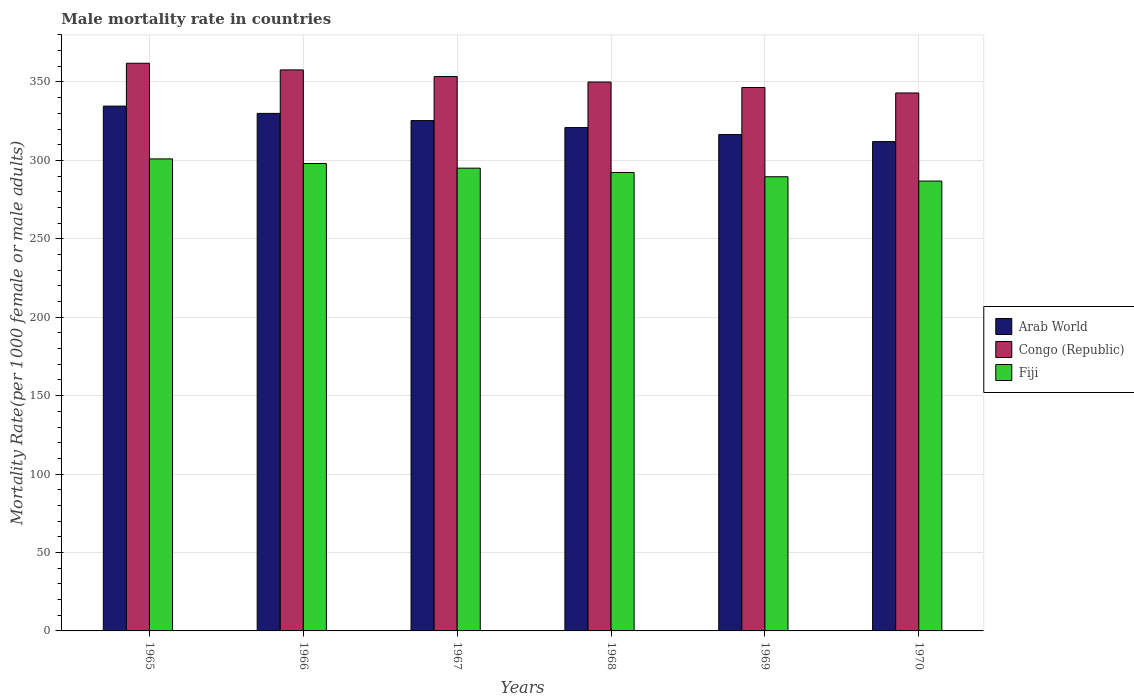How many different coloured bars are there?
Your answer should be very brief. 3. How many groups of bars are there?
Your answer should be compact. 6. Are the number of bars per tick equal to the number of legend labels?
Provide a succinct answer. Yes. Are the number of bars on each tick of the X-axis equal?
Your answer should be compact. Yes. How many bars are there on the 2nd tick from the left?
Offer a terse response. 3. How many bars are there on the 3rd tick from the right?
Your answer should be compact. 3. What is the male mortality rate in Congo (Republic) in 1969?
Your answer should be very brief. 346.49. Across all years, what is the maximum male mortality rate in Arab World?
Provide a succinct answer. 334.63. Across all years, what is the minimum male mortality rate in Fiji?
Give a very brief answer. 286.84. In which year was the male mortality rate in Arab World maximum?
Offer a terse response. 1965. What is the total male mortality rate in Congo (Republic) in the graph?
Your answer should be compact. 2112.6. What is the difference between the male mortality rate in Arab World in 1967 and that in 1970?
Your answer should be compact. 13.39. What is the difference between the male mortality rate in Arab World in 1965 and the male mortality rate in Congo (Republic) in 1970?
Provide a succinct answer. -8.37. What is the average male mortality rate in Congo (Republic) per year?
Keep it short and to the point. 352.1. In the year 1967, what is the difference between the male mortality rate in Arab World and male mortality rate in Fiji?
Provide a succinct answer. 30.32. What is the ratio of the male mortality rate in Arab World in 1966 to that in 1968?
Give a very brief answer. 1.03. What is the difference between the highest and the second highest male mortality rate in Fiji?
Offer a very short reply. 2.95. What is the difference between the highest and the lowest male mortality rate in Arab World?
Your response must be concise. 22.63. Is the sum of the male mortality rate in Arab World in 1967 and 1969 greater than the maximum male mortality rate in Congo (Republic) across all years?
Your answer should be very brief. Yes. What does the 2nd bar from the left in 1966 represents?
Ensure brevity in your answer.  Congo (Republic). What does the 3rd bar from the right in 1970 represents?
Your answer should be compact. Arab World. How many bars are there?
Give a very brief answer. 18. What is the difference between two consecutive major ticks on the Y-axis?
Your answer should be very brief. 50. Are the values on the major ticks of Y-axis written in scientific E-notation?
Your response must be concise. No. How many legend labels are there?
Ensure brevity in your answer.  3. What is the title of the graph?
Provide a succinct answer. Male mortality rate in countries. What is the label or title of the X-axis?
Your answer should be compact. Years. What is the label or title of the Y-axis?
Give a very brief answer. Mortality Rate(per 1000 female or male adults). What is the Mortality Rate(per 1000 female or male adults) of Arab World in 1965?
Give a very brief answer. 334.63. What is the Mortality Rate(per 1000 female or male adults) in Congo (Republic) in 1965?
Keep it short and to the point. 361.95. What is the Mortality Rate(per 1000 female or male adults) of Fiji in 1965?
Ensure brevity in your answer.  300.96. What is the Mortality Rate(per 1000 female or male adults) of Arab World in 1966?
Ensure brevity in your answer.  329.99. What is the Mortality Rate(per 1000 female or male adults) in Congo (Republic) in 1966?
Keep it short and to the point. 357.71. What is the Mortality Rate(per 1000 female or male adults) of Fiji in 1966?
Ensure brevity in your answer.  298.01. What is the Mortality Rate(per 1000 female or male adults) in Arab World in 1967?
Offer a terse response. 325.39. What is the Mortality Rate(per 1000 female or male adults) of Congo (Republic) in 1967?
Keep it short and to the point. 353.47. What is the Mortality Rate(per 1000 female or male adults) of Fiji in 1967?
Offer a terse response. 295.07. What is the Mortality Rate(per 1000 female or male adults) in Arab World in 1968?
Provide a succinct answer. 320.95. What is the Mortality Rate(per 1000 female or male adults) of Congo (Republic) in 1968?
Your response must be concise. 349.98. What is the Mortality Rate(per 1000 female or male adults) in Fiji in 1968?
Your answer should be compact. 292.33. What is the Mortality Rate(per 1000 female or male adults) of Arab World in 1969?
Ensure brevity in your answer.  316.49. What is the Mortality Rate(per 1000 female or male adults) in Congo (Republic) in 1969?
Your response must be concise. 346.49. What is the Mortality Rate(per 1000 female or male adults) in Fiji in 1969?
Provide a succinct answer. 289.58. What is the Mortality Rate(per 1000 female or male adults) in Arab World in 1970?
Your response must be concise. 312. What is the Mortality Rate(per 1000 female or male adults) of Congo (Republic) in 1970?
Your response must be concise. 343. What is the Mortality Rate(per 1000 female or male adults) of Fiji in 1970?
Your answer should be compact. 286.84. Across all years, what is the maximum Mortality Rate(per 1000 female or male adults) of Arab World?
Offer a very short reply. 334.63. Across all years, what is the maximum Mortality Rate(per 1000 female or male adults) of Congo (Republic)?
Provide a short and direct response. 361.95. Across all years, what is the maximum Mortality Rate(per 1000 female or male adults) of Fiji?
Ensure brevity in your answer.  300.96. Across all years, what is the minimum Mortality Rate(per 1000 female or male adults) of Arab World?
Offer a very short reply. 312. Across all years, what is the minimum Mortality Rate(per 1000 female or male adults) in Congo (Republic)?
Ensure brevity in your answer.  343. Across all years, what is the minimum Mortality Rate(per 1000 female or male adults) in Fiji?
Your response must be concise. 286.84. What is the total Mortality Rate(per 1000 female or male adults) in Arab World in the graph?
Give a very brief answer. 1939.45. What is the total Mortality Rate(per 1000 female or male adults) in Congo (Republic) in the graph?
Your answer should be compact. 2112.6. What is the total Mortality Rate(per 1000 female or male adults) in Fiji in the graph?
Your answer should be compact. 1762.8. What is the difference between the Mortality Rate(per 1000 female or male adults) in Arab World in 1965 and that in 1966?
Your answer should be compact. 4.64. What is the difference between the Mortality Rate(per 1000 female or male adults) in Congo (Republic) in 1965 and that in 1966?
Offer a terse response. 4.24. What is the difference between the Mortality Rate(per 1000 female or male adults) in Fiji in 1965 and that in 1966?
Your response must be concise. 2.95. What is the difference between the Mortality Rate(per 1000 female or male adults) in Arab World in 1965 and that in 1967?
Your response must be concise. 9.24. What is the difference between the Mortality Rate(per 1000 female or male adults) in Congo (Republic) in 1965 and that in 1967?
Your response must be concise. 8.47. What is the difference between the Mortality Rate(per 1000 female or male adults) of Fiji in 1965 and that in 1967?
Your answer should be very brief. 5.89. What is the difference between the Mortality Rate(per 1000 female or male adults) in Arab World in 1965 and that in 1968?
Ensure brevity in your answer.  13.68. What is the difference between the Mortality Rate(per 1000 female or male adults) in Congo (Republic) in 1965 and that in 1968?
Provide a succinct answer. 11.97. What is the difference between the Mortality Rate(per 1000 female or male adults) in Fiji in 1965 and that in 1968?
Offer a terse response. 8.63. What is the difference between the Mortality Rate(per 1000 female or male adults) of Arab World in 1965 and that in 1969?
Give a very brief answer. 18.14. What is the difference between the Mortality Rate(per 1000 female or male adults) of Congo (Republic) in 1965 and that in 1969?
Keep it short and to the point. 15.46. What is the difference between the Mortality Rate(per 1000 female or male adults) in Fiji in 1965 and that in 1969?
Offer a terse response. 11.38. What is the difference between the Mortality Rate(per 1000 female or male adults) in Arab World in 1965 and that in 1970?
Your answer should be compact. 22.63. What is the difference between the Mortality Rate(per 1000 female or male adults) of Congo (Republic) in 1965 and that in 1970?
Provide a short and direct response. 18.95. What is the difference between the Mortality Rate(per 1000 female or male adults) of Fiji in 1965 and that in 1970?
Ensure brevity in your answer.  14.12. What is the difference between the Mortality Rate(per 1000 female or male adults) in Arab World in 1966 and that in 1967?
Ensure brevity in your answer.  4.6. What is the difference between the Mortality Rate(per 1000 female or male adults) of Congo (Republic) in 1966 and that in 1967?
Give a very brief answer. 4.24. What is the difference between the Mortality Rate(per 1000 female or male adults) in Fiji in 1966 and that in 1967?
Offer a very short reply. 2.95. What is the difference between the Mortality Rate(per 1000 female or male adults) of Arab World in 1966 and that in 1968?
Provide a short and direct response. 9.04. What is the difference between the Mortality Rate(per 1000 female or male adults) of Congo (Republic) in 1966 and that in 1968?
Offer a terse response. 7.73. What is the difference between the Mortality Rate(per 1000 female or male adults) of Fiji in 1966 and that in 1968?
Your response must be concise. 5.69. What is the difference between the Mortality Rate(per 1000 female or male adults) of Arab World in 1966 and that in 1969?
Offer a very short reply. 13.5. What is the difference between the Mortality Rate(per 1000 female or male adults) in Congo (Republic) in 1966 and that in 1969?
Provide a succinct answer. 11.22. What is the difference between the Mortality Rate(per 1000 female or male adults) of Fiji in 1966 and that in 1969?
Provide a short and direct response. 8.43. What is the difference between the Mortality Rate(per 1000 female or male adults) in Arab World in 1966 and that in 1970?
Make the answer very short. 17.99. What is the difference between the Mortality Rate(per 1000 female or male adults) in Congo (Republic) in 1966 and that in 1970?
Your response must be concise. 14.71. What is the difference between the Mortality Rate(per 1000 female or male adults) in Fiji in 1966 and that in 1970?
Your answer should be compact. 11.17. What is the difference between the Mortality Rate(per 1000 female or male adults) in Arab World in 1967 and that in 1968?
Offer a terse response. 4.44. What is the difference between the Mortality Rate(per 1000 female or male adults) in Congo (Republic) in 1967 and that in 1968?
Ensure brevity in your answer.  3.49. What is the difference between the Mortality Rate(per 1000 female or male adults) of Fiji in 1967 and that in 1968?
Keep it short and to the point. 2.74. What is the difference between the Mortality Rate(per 1000 female or male adults) of Arab World in 1967 and that in 1969?
Ensure brevity in your answer.  8.9. What is the difference between the Mortality Rate(per 1000 female or male adults) in Congo (Republic) in 1967 and that in 1969?
Ensure brevity in your answer.  6.98. What is the difference between the Mortality Rate(per 1000 female or male adults) of Fiji in 1967 and that in 1969?
Offer a terse response. 5.48. What is the difference between the Mortality Rate(per 1000 female or male adults) in Arab World in 1967 and that in 1970?
Make the answer very short. 13.39. What is the difference between the Mortality Rate(per 1000 female or male adults) in Congo (Republic) in 1967 and that in 1970?
Your answer should be very brief. 10.48. What is the difference between the Mortality Rate(per 1000 female or male adults) in Fiji in 1967 and that in 1970?
Your answer should be compact. 8.22. What is the difference between the Mortality Rate(per 1000 female or male adults) in Arab World in 1968 and that in 1969?
Provide a succinct answer. 4.46. What is the difference between the Mortality Rate(per 1000 female or male adults) of Congo (Republic) in 1968 and that in 1969?
Offer a very short reply. 3.49. What is the difference between the Mortality Rate(per 1000 female or male adults) in Fiji in 1968 and that in 1969?
Provide a succinct answer. 2.74. What is the difference between the Mortality Rate(per 1000 female or male adults) in Arab World in 1968 and that in 1970?
Offer a very short reply. 8.95. What is the difference between the Mortality Rate(per 1000 female or male adults) in Congo (Republic) in 1968 and that in 1970?
Offer a terse response. 6.98. What is the difference between the Mortality Rate(per 1000 female or male adults) of Fiji in 1968 and that in 1970?
Your answer should be very brief. 5.48. What is the difference between the Mortality Rate(per 1000 female or male adults) of Arab World in 1969 and that in 1970?
Your response must be concise. 4.49. What is the difference between the Mortality Rate(per 1000 female or male adults) in Congo (Republic) in 1969 and that in 1970?
Your answer should be very brief. 3.49. What is the difference between the Mortality Rate(per 1000 female or male adults) in Fiji in 1969 and that in 1970?
Offer a very short reply. 2.74. What is the difference between the Mortality Rate(per 1000 female or male adults) of Arab World in 1965 and the Mortality Rate(per 1000 female or male adults) of Congo (Republic) in 1966?
Make the answer very short. -23.08. What is the difference between the Mortality Rate(per 1000 female or male adults) of Arab World in 1965 and the Mortality Rate(per 1000 female or male adults) of Fiji in 1966?
Offer a terse response. 36.62. What is the difference between the Mortality Rate(per 1000 female or male adults) of Congo (Republic) in 1965 and the Mortality Rate(per 1000 female or male adults) of Fiji in 1966?
Your answer should be very brief. 63.93. What is the difference between the Mortality Rate(per 1000 female or male adults) in Arab World in 1965 and the Mortality Rate(per 1000 female or male adults) in Congo (Republic) in 1967?
Make the answer very short. -18.84. What is the difference between the Mortality Rate(per 1000 female or male adults) of Arab World in 1965 and the Mortality Rate(per 1000 female or male adults) of Fiji in 1967?
Provide a succinct answer. 39.56. What is the difference between the Mortality Rate(per 1000 female or male adults) in Congo (Republic) in 1965 and the Mortality Rate(per 1000 female or male adults) in Fiji in 1967?
Your response must be concise. 66.88. What is the difference between the Mortality Rate(per 1000 female or male adults) of Arab World in 1965 and the Mortality Rate(per 1000 female or male adults) of Congo (Republic) in 1968?
Your response must be concise. -15.35. What is the difference between the Mortality Rate(per 1000 female or male adults) in Arab World in 1965 and the Mortality Rate(per 1000 female or male adults) in Fiji in 1968?
Make the answer very short. 42.3. What is the difference between the Mortality Rate(per 1000 female or male adults) in Congo (Republic) in 1965 and the Mortality Rate(per 1000 female or male adults) in Fiji in 1968?
Offer a terse response. 69.62. What is the difference between the Mortality Rate(per 1000 female or male adults) in Arab World in 1965 and the Mortality Rate(per 1000 female or male adults) in Congo (Republic) in 1969?
Keep it short and to the point. -11.86. What is the difference between the Mortality Rate(per 1000 female or male adults) of Arab World in 1965 and the Mortality Rate(per 1000 female or male adults) of Fiji in 1969?
Keep it short and to the point. 45.05. What is the difference between the Mortality Rate(per 1000 female or male adults) in Congo (Republic) in 1965 and the Mortality Rate(per 1000 female or male adults) in Fiji in 1969?
Provide a succinct answer. 72.36. What is the difference between the Mortality Rate(per 1000 female or male adults) in Arab World in 1965 and the Mortality Rate(per 1000 female or male adults) in Congo (Republic) in 1970?
Ensure brevity in your answer.  -8.37. What is the difference between the Mortality Rate(per 1000 female or male adults) of Arab World in 1965 and the Mortality Rate(per 1000 female or male adults) of Fiji in 1970?
Provide a succinct answer. 47.79. What is the difference between the Mortality Rate(per 1000 female or male adults) in Congo (Republic) in 1965 and the Mortality Rate(per 1000 female or male adults) in Fiji in 1970?
Ensure brevity in your answer.  75.1. What is the difference between the Mortality Rate(per 1000 female or male adults) of Arab World in 1966 and the Mortality Rate(per 1000 female or male adults) of Congo (Republic) in 1967?
Provide a succinct answer. -23.48. What is the difference between the Mortality Rate(per 1000 female or male adults) in Arab World in 1966 and the Mortality Rate(per 1000 female or male adults) in Fiji in 1967?
Offer a terse response. 34.92. What is the difference between the Mortality Rate(per 1000 female or male adults) in Congo (Republic) in 1966 and the Mortality Rate(per 1000 female or male adults) in Fiji in 1967?
Your answer should be very brief. 62.64. What is the difference between the Mortality Rate(per 1000 female or male adults) in Arab World in 1966 and the Mortality Rate(per 1000 female or male adults) in Congo (Republic) in 1968?
Give a very brief answer. -19.99. What is the difference between the Mortality Rate(per 1000 female or male adults) of Arab World in 1966 and the Mortality Rate(per 1000 female or male adults) of Fiji in 1968?
Make the answer very short. 37.66. What is the difference between the Mortality Rate(per 1000 female or male adults) in Congo (Republic) in 1966 and the Mortality Rate(per 1000 female or male adults) in Fiji in 1968?
Provide a succinct answer. 65.38. What is the difference between the Mortality Rate(per 1000 female or male adults) of Arab World in 1966 and the Mortality Rate(per 1000 female or male adults) of Congo (Republic) in 1969?
Your answer should be very brief. -16.5. What is the difference between the Mortality Rate(per 1000 female or male adults) of Arab World in 1966 and the Mortality Rate(per 1000 female or male adults) of Fiji in 1969?
Your answer should be compact. 40.41. What is the difference between the Mortality Rate(per 1000 female or male adults) of Congo (Republic) in 1966 and the Mortality Rate(per 1000 female or male adults) of Fiji in 1969?
Provide a short and direct response. 68.13. What is the difference between the Mortality Rate(per 1000 female or male adults) in Arab World in 1966 and the Mortality Rate(per 1000 female or male adults) in Congo (Republic) in 1970?
Your response must be concise. -13.01. What is the difference between the Mortality Rate(per 1000 female or male adults) in Arab World in 1966 and the Mortality Rate(per 1000 female or male adults) in Fiji in 1970?
Ensure brevity in your answer.  43.15. What is the difference between the Mortality Rate(per 1000 female or male adults) in Congo (Republic) in 1966 and the Mortality Rate(per 1000 female or male adults) in Fiji in 1970?
Give a very brief answer. 70.87. What is the difference between the Mortality Rate(per 1000 female or male adults) of Arab World in 1967 and the Mortality Rate(per 1000 female or male adults) of Congo (Republic) in 1968?
Provide a short and direct response. -24.59. What is the difference between the Mortality Rate(per 1000 female or male adults) of Arab World in 1967 and the Mortality Rate(per 1000 female or male adults) of Fiji in 1968?
Ensure brevity in your answer.  33.06. What is the difference between the Mortality Rate(per 1000 female or male adults) of Congo (Republic) in 1967 and the Mortality Rate(per 1000 female or male adults) of Fiji in 1968?
Give a very brief answer. 61.15. What is the difference between the Mortality Rate(per 1000 female or male adults) in Arab World in 1967 and the Mortality Rate(per 1000 female or male adults) in Congo (Republic) in 1969?
Keep it short and to the point. -21.1. What is the difference between the Mortality Rate(per 1000 female or male adults) of Arab World in 1967 and the Mortality Rate(per 1000 female or male adults) of Fiji in 1969?
Give a very brief answer. 35.81. What is the difference between the Mortality Rate(per 1000 female or male adults) in Congo (Republic) in 1967 and the Mortality Rate(per 1000 female or male adults) in Fiji in 1969?
Provide a short and direct response. 63.89. What is the difference between the Mortality Rate(per 1000 female or male adults) in Arab World in 1967 and the Mortality Rate(per 1000 female or male adults) in Congo (Republic) in 1970?
Provide a succinct answer. -17.61. What is the difference between the Mortality Rate(per 1000 female or male adults) of Arab World in 1967 and the Mortality Rate(per 1000 female or male adults) of Fiji in 1970?
Provide a succinct answer. 38.55. What is the difference between the Mortality Rate(per 1000 female or male adults) of Congo (Republic) in 1967 and the Mortality Rate(per 1000 female or male adults) of Fiji in 1970?
Your answer should be compact. 66.63. What is the difference between the Mortality Rate(per 1000 female or male adults) in Arab World in 1968 and the Mortality Rate(per 1000 female or male adults) in Congo (Republic) in 1969?
Your answer should be compact. -25.54. What is the difference between the Mortality Rate(per 1000 female or male adults) of Arab World in 1968 and the Mortality Rate(per 1000 female or male adults) of Fiji in 1969?
Your answer should be very brief. 31.37. What is the difference between the Mortality Rate(per 1000 female or male adults) of Congo (Republic) in 1968 and the Mortality Rate(per 1000 female or male adults) of Fiji in 1969?
Your answer should be very brief. 60.4. What is the difference between the Mortality Rate(per 1000 female or male adults) of Arab World in 1968 and the Mortality Rate(per 1000 female or male adults) of Congo (Republic) in 1970?
Give a very brief answer. -22.05. What is the difference between the Mortality Rate(per 1000 female or male adults) in Arab World in 1968 and the Mortality Rate(per 1000 female or male adults) in Fiji in 1970?
Your answer should be compact. 34.11. What is the difference between the Mortality Rate(per 1000 female or male adults) in Congo (Republic) in 1968 and the Mortality Rate(per 1000 female or male adults) in Fiji in 1970?
Provide a short and direct response. 63.14. What is the difference between the Mortality Rate(per 1000 female or male adults) in Arab World in 1969 and the Mortality Rate(per 1000 female or male adults) in Congo (Republic) in 1970?
Make the answer very short. -26.51. What is the difference between the Mortality Rate(per 1000 female or male adults) in Arab World in 1969 and the Mortality Rate(per 1000 female or male adults) in Fiji in 1970?
Provide a short and direct response. 29.65. What is the difference between the Mortality Rate(per 1000 female or male adults) of Congo (Republic) in 1969 and the Mortality Rate(per 1000 female or male adults) of Fiji in 1970?
Provide a short and direct response. 59.65. What is the average Mortality Rate(per 1000 female or male adults) of Arab World per year?
Your answer should be compact. 323.24. What is the average Mortality Rate(per 1000 female or male adults) of Congo (Republic) per year?
Provide a succinct answer. 352.1. What is the average Mortality Rate(per 1000 female or male adults) in Fiji per year?
Offer a very short reply. 293.8. In the year 1965, what is the difference between the Mortality Rate(per 1000 female or male adults) in Arab World and Mortality Rate(per 1000 female or male adults) in Congo (Republic)?
Keep it short and to the point. -27.32. In the year 1965, what is the difference between the Mortality Rate(per 1000 female or male adults) in Arab World and Mortality Rate(per 1000 female or male adults) in Fiji?
Provide a short and direct response. 33.67. In the year 1965, what is the difference between the Mortality Rate(per 1000 female or male adults) of Congo (Republic) and Mortality Rate(per 1000 female or male adults) of Fiji?
Keep it short and to the point. 60.99. In the year 1966, what is the difference between the Mortality Rate(per 1000 female or male adults) in Arab World and Mortality Rate(per 1000 female or male adults) in Congo (Republic)?
Offer a very short reply. -27.72. In the year 1966, what is the difference between the Mortality Rate(per 1000 female or male adults) of Arab World and Mortality Rate(per 1000 female or male adults) of Fiji?
Your response must be concise. 31.98. In the year 1966, what is the difference between the Mortality Rate(per 1000 female or male adults) in Congo (Republic) and Mortality Rate(per 1000 female or male adults) in Fiji?
Your answer should be compact. 59.7. In the year 1967, what is the difference between the Mortality Rate(per 1000 female or male adults) in Arab World and Mortality Rate(per 1000 female or male adults) in Congo (Republic)?
Provide a short and direct response. -28.08. In the year 1967, what is the difference between the Mortality Rate(per 1000 female or male adults) of Arab World and Mortality Rate(per 1000 female or male adults) of Fiji?
Provide a short and direct response. 30.32. In the year 1967, what is the difference between the Mortality Rate(per 1000 female or male adults) of Congo (Republic) and Mortality Rate(per 1000 female or male adults) of Fiji?
Provide a succinct answer. 58.41. In the year 1968, what is the difference between the Mortality Rate(per 1000 female or male adults) in Arab World and Mortality Rate(per 1000 female or male adults) in Congo (Republic)?
Provide a short and direct response. -29.03. In the year 1968, what is the difference between the Mortality Rate(per 1000 female or male adults) of Arab World and Mortality Rate(per 1000 female or male adults) of Fiji?
Give a very brief answer. 28.62. In the year 1968, what is the difference between the Mortality Rate(per 1000 female or male adults) of Congo (Republic) and Mortality Rate(per 1000 female or male adults) of Fiji?
Make the answer very short. 57.66. In the year 1969, what is the difference between the Mortality Rate(per 1000 female or male adults) in Arab World and Mortality Rate(per 1000 female or male adults) in Congo (Republic)?
Give a very brief answer. -30. In the year 1969, what is the difference between the Mortality Rate(per 1000 female or male adults) in Arab World and Mortality Rate(per 1000 female or male adults) in Fiji?
Your answer should be very brief. 26.91. In the year 1969, what is the difference between the Mortality Rate(per 1000 female or male adults) in Congo (Republic) and Mortality Rate(per 1000 female or male adults) in Fiji?
Your answer should be very brief. 56.91. In the year 1970, what is the difference between the Mortality Rate(per 1000 female or male adults) in Arab World and Mortality Rate(per 1000 female or male adults) in Congo (Republic)?
Your answer should be compact. -31. In the year 1970, what is the difference between the Mortality Rate(per 1000 female or male adults) of Arab World and Mortality Rate(per 1000 female or male adults) of Fiji?
Your answer should be very brief. 25.16. In the year 1970, what is the difference between the Mortality Rate(per 1000 female or male adults) in Congo (Republic) and Mortality Rate(per 1000 female or male adults) in Fiji?
Ensure brevity in your answer.  56.15. What is the ratio of the Mortality Rate(per 1000 female or male adults) of Arab World in 1965 to that in 1966?
Provide a succinct answer. 1.01. What is the ratio of the Mortality Rate(per 1000 female or male adults) of Congo (Republic) in 1965 to that in 1966?
Provide a succinct answer. 1.01. What is the ratio of the Mortality Rate(per 1000 female or male adults) of Fiji in 1965 to that in 1966?
Make the answer very short. 1.01. What is the ratio of the Mortality Rate(per 1000 female or male adults) of Arab World in 1965 to that in 1967?
Your response must be concise. 1.03. What is the ratio of the Mortality Rate(per 1000 female or male adults) in Fiji in 1965 to that in 1967?
Keep it short and to the point. 1.02. What is the ratio of the Mortality Rate(per 1000 female or male adults) of Arab World in 1965 to that in 1968?
Provide a short and direct response. 1.04. What is the ratio of the Mortality Rate(per 1000 female or male adults) of Congo (Republic) in 1965 to that in 1968?
Offer a very short reply. 1.03. What is the ratio of the Mortality Rate(per 1000 female or male adults) in Fiji in 1965 to that in 1968?
Offer a very short reply. 1.03. What is the ratio of the Mortality Rate(per 1000 female or male adults) in Arab World in 1965 to that in 1969?
Give a very brief answer. 1.06. What is the ratio of the Mortality Rate(per 1000 female or male adults) of Congo (Republic) in 1965 to that in 1969?
Keep it short and to the point. 1.04. What is the ratio of the Mortality Rate(per 1000 female or male adults) in Fiji in 1965 to that in 1969?
Provide a succinct answer. 1.04. What is the ratio of the Mortality Rate(per 1000 female or male adults) in Arab World in 1965 to that in 1970?
Make the answer very short. 1.07. What is the ratio of the Mortality Rate(per 1000 female or male adults) in Congo (Republic) in 1965 to that in 1970?
Make the answer very short. 1.06. What is the ratio of the Mortality Rate(per 1000 female or male adults) in Fiji in 1965 to that in 1970?
Offer a terse response. 1.05. What is the ratio of the Mortality Rate(per 1000 female or male adults) of Arab World in 1966 to that in 1967?
Your answer should be very brief. 1.01. What is the ratio of the Mortality Rate(per 1000 female or male adults) in Fiji in 1966 to that in 1967?
Your answer should be compact. 1.01. What is the ratio of the Mortality Rate(per 1000 female or male adults) in Arab World in 1966 to that in 1968?
Provide a succinct answer. 1.03. What is the ratio of the Mortality Rate(per 1000 female or male adults) of Congo (Republic) in 1966 to that in 1968?
Give a very brief answer. 1.02. What is the ratio of the Mortality Rate(per 1000 female or male adults) of Fiji in 1966 to that in 1968?
Keep it short and to the point. 1.02. What is the ratio of the Mortality Rate(per 1000 female or male adults) in Arab World in 1966 to that in 1969?
Keep it short and to the point. 1.04. What is the ratio of the Mortality Rate(per 1000 female or male adults) in Congo (Republic) in 1966 to that in 1969?
Ensure brevity in your answer.  1.03. What is the ratio of the Mortality Rate(per 1000 female or male adults) in Fiji in 1966 to that in 1969?
Keep it short and to the point. 1.03. What is the ratio of the Mortality Rate(per 1000 female or male adults) in Arab World in 1966 to that in 1970?
Your response must be concise. 1.06. What is the ratio of the Mortality Rate(per 1000 female or male adults) in Congo (Republic) in 1966 to that in 1970?
Your answer should be very brief. 1.04. What is the ratio of the Mortality Rate(per 1000 female or male adults) of Fiji in 1966 to that in 1970?
Provide a short and direct response. 1.04. What is the ratio of the Mortality Rate(per 1000 female or male adults) of Arab World in 1967 to that in 1968?
Your answer should be compact. 1.01. What is the ratio of the Mortality Rate(per 1000 female or male adults) in Fiji in 1967 to that in 1968?
Make the answer very short. 1.01. What is the ratio of the Mortality Rate(per 1000 female or male adults) in Arab World in 1967 to that in 1969?
Provide a short and direct response. 1.03. What is the ratio of the Mortality Rate(per 1000 female or male adults) of Congo (Republic) in 1967 to that in 1969?
Ensure brevity in your answer.  1.02. What is the ratio of the Mortality Rate(per 1000 female or male adults) in Fiji in 1967 to that in 1969?
Make the answer very short. 1.02. What is the ratio of the Mortality Rate(per 1000 female or male adults) of Arab World in 1967 to that in 1970?
Offer a very short reply. 1.04. What is the ratio of the Mortality Rate(per 1000 female or male adults) of Congo (Republic) in 1967 to that in 1970?
Keep it short and to the point. 1.03. What is the ratio of the Mortality Rate(per 1000 female or male adults) in Fiji in 1967 to that in 1970?
Your response must be concise. 1.03. What is the ratio of the Mortality Rate(per 1000 female or male adults) of Arab World in 1968 to that in 1969?
Provide a succinct answer. 1.01. What is the ratio of the Mortality Rate(per 1000 female or male adults) in Fiji in 1968 to that in 1969?
Provide a short and direct response. 1.01. What is the ratio of the Mortality Rate(per 1000 female or male adults) in Arab World in 1968 to that in 1970?
Provide a short and direct response. 1.03. What is the ratio of the Mortality Rate(per 1000 female or male adults) of Congo (Republic) in 1968 to that in 1970?
Your answer should be very brief. 1.02. What is the ratio of the Mortality Rate(per 1000 female or male adults) of Fiji in 1968 to that in 1970?
Give a very brief answer. 1.02. What is the ratio of the Mortality Rate(per 1000 female or male adults) of Arab World in 1969 to that in 1970?
Your answer should be compact. 1.01. What is the ratio of the Mortality Rate(per 1000 female or male adults) in Congo (Republic) in 1969 to that in 1970?
Ensure brevity in your answer.  1.01. What is the ratio of the Mortality Rate(per 1000 female or male adults) in Fiji in 1969 to that in 1970?
Your answer should be compact. 1.01. What is the difference between the highest and the second highest Mortality Rate(per 1000 female or male adults) in Arab World?
Give a very brief answer. 4.64. What is the difference between the highest and the second highest Mortality Rate(per 1000 female or male adults) of Congo (Republic)?
Ensure brevity in your answer.  4.24. What is the difference between the highest and the second highest Mortality Rate(per 1000 female or male adults) of Fiji?
Provide a succinct answer. 2.95. What is the difference between the highest and the lowest Mortality Rate(per 1000 female or male adults) of Arab World?
Your answer should be very brief. 22.63. What is the difference between the highest and the lowest Mortality Rate(per 1000 female or male adults) of Congo (Republic)?
Make the answer very short. 18.95. What is the difference between the highest and the lowest Mortality Rate(per 1000 female or male adults) in Fiji?
Make the answer very short. 14.12. 